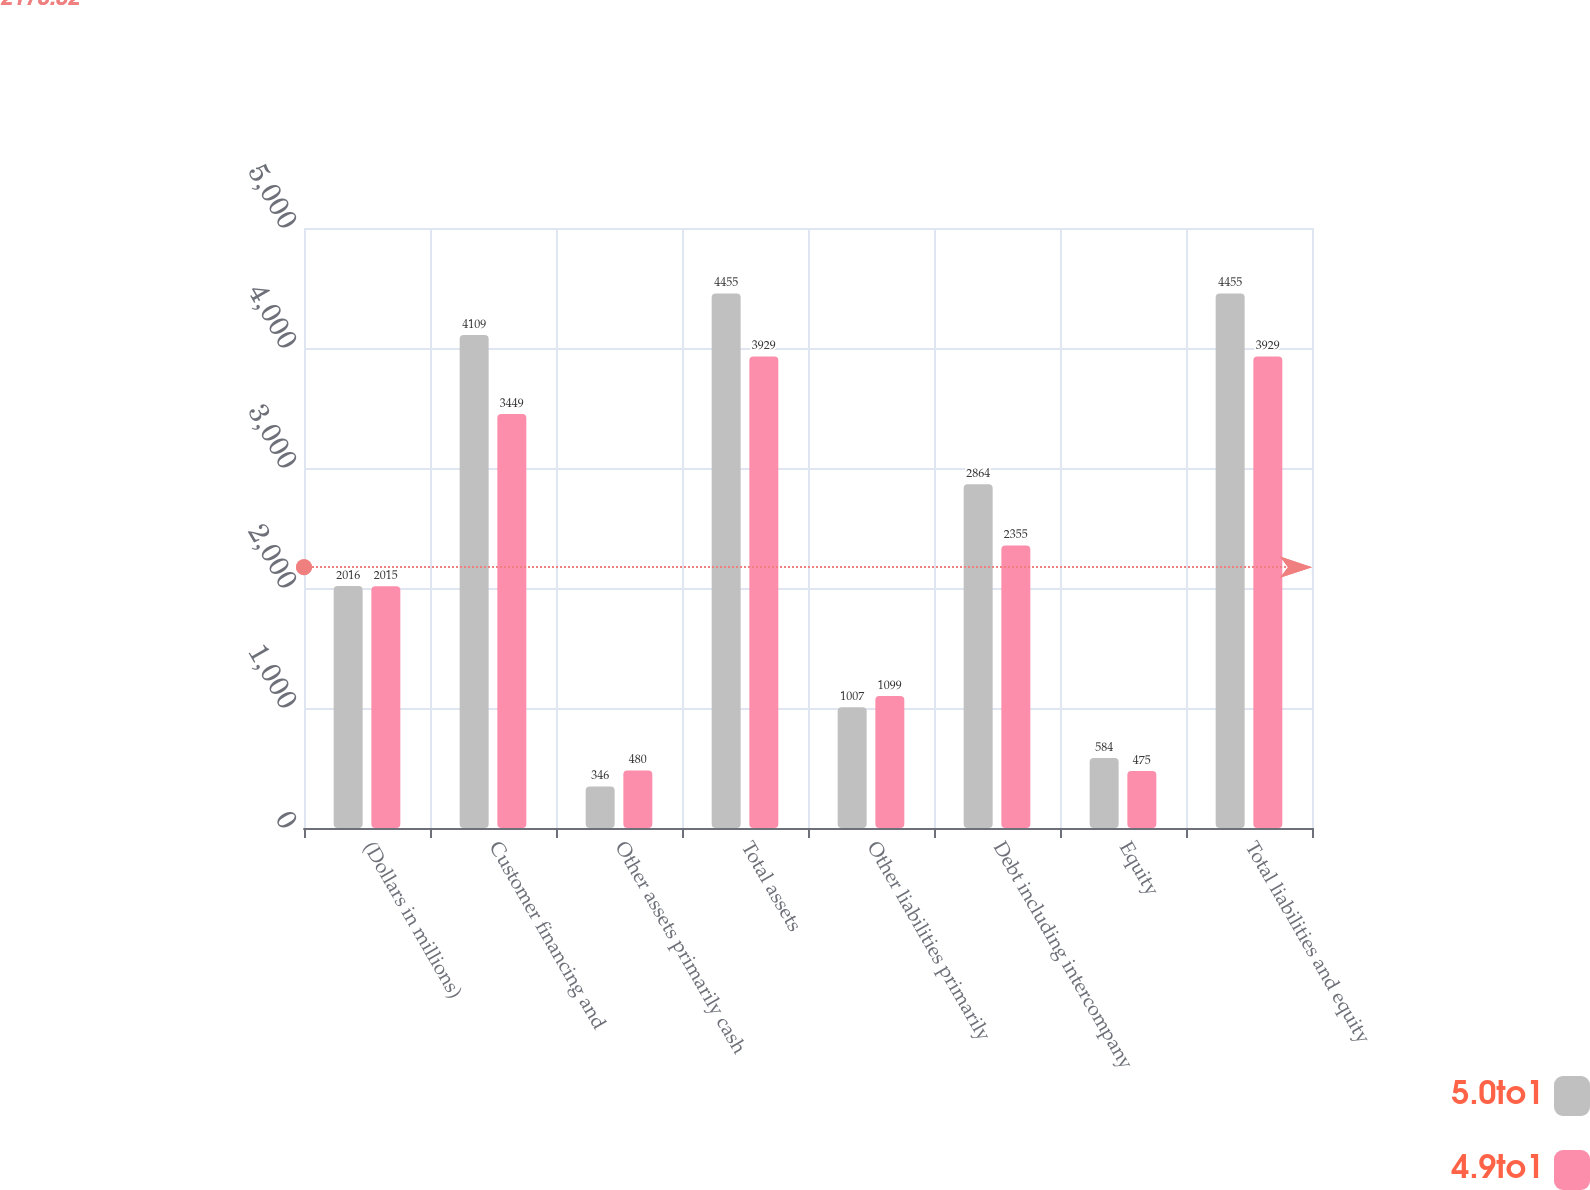Convert chart. <chart><loc_0><loc_0><loc_500><loc_500><stacked_bar_chart><ecel><fcel>(Dollars in millions)<fcel>Customer financing and<fcel>Other assets primarily cash<fcel>Total assets<fcel>Other liabilities primarily<fcel>Debt including intercompany<fcel>Equity<fcel>Total liabilities and equity<nl><fcel>5.0to1<fcel>2016<fcel>4109<fcel>346<fcel>4455<fcel>1007<fcel>2864<fcel>584<fcel>4455<nl><fcel>4.9to1<fcel>2015<fcel>3449<fcel>480<fcel>3929<fcel>1099<fcel>2355<fcel>475<fcel>3929<nl></chart> 